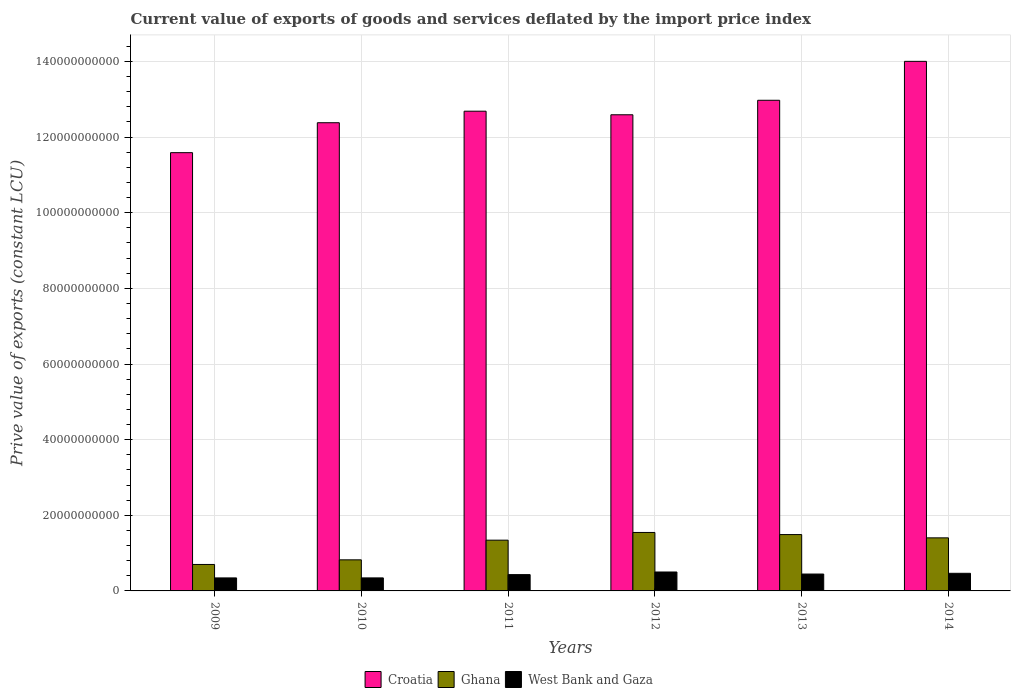How many different coloured bars are there?
Your response must be concise. 3. How many bars are there on the 6th tick from the right?
Your answer should be very brief. 3. What is the prive value of exports in Croatia in 2012?
Give a very brief answer. 1.26e+11. Across all years, what is the maximum prive value of exports in West Bank and Gaza?
Provide a short and direct response. 5.00e+09. Across all years, what is the minimum prive value of exports in Croatia?
Your response must be concise. 1.16e+11. In which year was the prive value of exports in Ghana minimum?
Provide a succinct answer. 2009. What is the total prive value of exports in Croatia in the graph?
Provide a succinct answer. 7.62e+11. What is the difference between the prive value of exports in Croatia in 2013 and that in 2014?
Provide a succinct answer. -1.03e+1. What is the difference between the prive value of exports in West Bank and Gaza in 2010 and the prive value of exports in Croatia in 2014?
Provide a succinct answer. -1.37e+11. What is the average prive value of exports in Ghana per year?
Your answer should be very brief. 1.22e+1. In the year 2012, what is the difference between the prive value of exports in West Bank and Gaza and prive value of exports in Ghana?
Provide a short and direct response. -1.05e+1. In how many years, is the prive value of exports in West Bank and Gaza greater than 108000000000 LCU?
Ensure brevity in your answer.  0. What is the ratio of the prive value of exports in Croatia in 2010 to that in 2011?
Your response must be concise. 0.98. What is the difference between the highest and the second highest prive value of exports in Croatia?
Ensure brevity in your answer.  1.03e+1. What is the difference between the highest and the lowest prive value of exports in Ghana?
Keep it short and to the point. 8.46e+09. In how many years, is the prive value of exports in West Bank and Gaza greater than the average prive value of exports in West Bank and Gaza taken over all years?
Give a very brief answer. 4. What does the 1st bar from the left in 2014 represents?
Offer a very short reply. Croatia. What does the 3rd bar from the right in 2012 represents?
Provide a succinct answer. Croatia. Is it the case that in every year, the sum of the prive value of exports in Croatia and prive value of exports in Ghana is greater than the prive value of exports in West Bank and Gaza?
Give a very brief answer. Yes. Does the graph contain any zero values?
Your answer should be compact. No. Does the graph contain grids?
Offer a terse response. Yes. How are the legend labels stacked?
Give a very brief answer. Horizontal. What is the title of the graph?
Provide a short and direct response. Current value of exports of goods and services deflated by the import price index. What is the label or title of the Y-axis?
Your response must be concise. Prive value of exports (constant LCU). What is the Prive value of exports (constant LCU) in Croatia in 2009?
Your response must be concise. 1.16e+11. What is the Prive value of exports (constant LCU) in Ghana in 2009?
Ensure brevity in your answer.  7.00e+09. What is the Prive value of exports (constant LCU) of West Bank and Gaza in 2009?
Provide a short and direct response. 3.44e+09. What is the Prive value of exports (constant LCU) of Croatia in 2010?
Provide a short and direct response. 1.24e+11. What is the Prive value of exports (constant LCU) in Ghana in 2010?
Your answer should be very brief. 8.22e+09. What is the Prive value of exports (constant LCU) of West Bank and Gaza in 2010?
Give a very brief answer. 3.44e+09. What is the Prive value of exports (constant LCU) in Croatia in 2011?
Make the answer very short. 1.27e+11. What is the Prive value of exports (constant LCU) of Ghana in 2011?
Offer a very short reply. 1.34e+1. What is the Prive value of exports (constant LCU) in West Bank and Gaza in 2011?
Make the answer very short. 4.31e+09. What is the Prive value of exports (constant LCU) of Croatia in 2012?
Make the answer very short. 1.26e+11. What is the Prive value of exports (constant LCU) of Ghana in 2012?
Offer a terse response. 1.55e+1. What is the Prive value of exports (constant LCU) of West Bank and Gaza in 2012?
Provide a succinct answer. 5.00e+09. What is the Prive value of exports (constant LCU) in Croatia in 2013?
Keep it short and to the point. 1.30e+11. What is the Prive value of exports (constant LCU) in Ghana in 2013?
Offer a terse response. 1.49e+1. What is the Prive value of exports (constant LCU) of West Bank and Gaza in 2013?
Keep it short and to the point. 4.46e+09. What is the Prive value of exports (constant LCU) of Croatia in 2014?
Offer a very short reply. 1.40e+11. What is the Prive value of exports (constant LCU) in Ghana in 2014?
Offer a very short reply. 1.40e+1. What is the Prive value of exports (constant LCU) in West Bank and Gaza in 2014?
Ensure brevity in your answer.  4.66e+09. Across all years, what is the maximum Prive value of exports (constant LCU) in Croatia?
Give a very brief answer. 1.40e+11. Across all years, what is the maximum Prive value of exports (constant LCU) of Ghana?
Your response must be concise. 1.55e+1. Across all years, what is the maximum Prive value of exports (constant LCU) in West Bank and Gaza?
Your answer should be compact. 5.00e+09. Across all years, what is the minimum Prive value of exports (constant LCU) of Croatia?
Give a very brief answer. 1.16e+11. Across all years, what is the minimum Prive value of exports (constant LCU) of Ghana?
Keep it short and to the point. 7.00e+09. Across all years, what is the minimum Prive value of exports (constant LCU) in West Bank and Gaza?
Provide a succinct answer. 3.44e+09. What is the total Prive value of exports (constant LCU) of Croatia in the graph?
Your answer should be very brief. 7.62e+11. What is the total Prive value of exports (constant LCU) of Ghana in the graph?
Offer a very short reply. 7.30e+1. What is the total Prive value of exports (constant LCU) of West Bank and Gaza in the graph?
Give a very brief answer. 2.53e+1. What is the difference between the Prive value of exports (constant LCU) of Croatia in 2009 and that in 2010?
Offer a terse response. -7.92e+09. What is the difference between the Prive value of exports (constant LCU) of Ghana in 2009 and that in 2010?
Make the answer very short. -1.22e+09. What is the difference between the Prive value of exports (constant LCU) in West Bank and Gaza in 2009 and that in 2010?
Make the answer very short. -4.18e+06. What is the difference between the Prive value of exports (constant LCU) of Croatia in 2009 and that in 2011?
Make the answer very short. -1.10e+1. What is the difference between the Prive value of exports (constant LCU) in Ghana in 2009 and that in 2011?
Your response must be concise. -6.42e+09. What is the difference between the Prive value of exports (constant LCU) in West Bank and Gaza in 2009 and that in 2011?
Keep it short and to the point. -8.70e+08. What is the difference between the Prive value of exports (constant LCU) in Croatia in 2009 and that in 2012?
Offer a terse response. -1.00e+1. What is the difference between the Prive value of exports (constant LCU) in Ghana in 2009 and that in 2012?
Offer a terse response. -8.46e+09. What is the difference between the Prive value of exports (constant LCU) in West Bank and Gaza in 2009 and that in 2012?
Provide a succinct answer. -1.56e+09. What is the difference between the Prive value of exports (constant LCU) of Croatia in 2009 and that in 2013?
Keep it short and to the point. -1.39e+1. What is the difference between the Prive value of exports (constant LCU) in Ghana in 2009 and that in 2013?
Provide a succinct answer. -7.90e+09. What is the difference between the Prive value of exports (constant LCU) in West Bank and Gaza in 2009 and that in 2013?
Your answer should be compact. -1.02e+09. What is the difference between the Prive value of exports (constant LCU) of Croatia in 2009 and that in 2014?
Ensure brevity in your answer.  -2.41e+1. What is the difference between the Prive value of exports (constant LCU) in Ghana in 2009 and that in 2014?
Provide a short and direct response. -7.03e+09. What is the difference between the Prive value of exports (constant LCU) of West Bank and Gaza in 2009 and that in 2014?
Offer a very short reply. -1.22e+09. What is the difference between the Prive value of exports (constant LCU) in Croatia in 2010 and that in 2011?
Provide a short and direct response. -3.05e+09. What is the difference between the Prive value of exports (constant LCU) in Ghana in 2010 and that in 2011?
Make the answer very short. -5.20e+09. What is the difference between the Prive value of exports (constant LCU) of West Bank and Gaza in 2010 and that in 2011?
Your response must be concise. -8.66e+08. What is the difference between the Prive value of exports (constant LCU) of Croatia in 2010 and that in 2012?
Provide a succinct answer. -2.11e+09. What is the difference between the Prive value of exports (constant LCU) in Ghana in 2010 and that in 2012?
Your answer should be compact. -7.24e+09. What is the difference between the Prive value of exports (constant LCU) of West Bank and Gaza in 2010 and that in 2012?
Your response must be concise. -1.56e+09. What is the difference between the Prive value of exports (constant LCU) in Croatia in 2010 and that in 2013?
Offer a terse response. -5.94e+09. What is the difference between the Prive value of exports (constant LCU) of Ghana in 2010 and that in 2013?
Offer a terse response. -6.68e+09. What is the difference between the Prive value of exports (constant LCU) of West Bank and Gaza in 2010 and that in 2013?
Provide a short and direct response. -1.02e+09. What is the difference between the Prive value of exports (constant LCU) in Croatia in 2010 and that in 2014?
Offer a terse response. -1.62e+1. What is the difference between the Prive value of exports (constant LCU) of Ghana in 2010 and that in 2014?
Provide a short and direct response. -5.81e+09. What is the difference between the Prive value of exports (constant LCU) of West Bank and Gaza in 2010 and that in 2014?
Make the answer very short. -1.21e+09. What is the difference between the Prive value of exports (constant LCU) of Croatia in 2011 and that in 2012?
Ensure brevity in your answer.  9.46e+08. What is the difference between the Prive value of exports (constant LCU) of Ghana in 2011 and that in 2012?
Offer a terse response. -2.04e+09. What is the difference between the Prive value of exports (constant LCU) of West Bank and Gaza in 2011 and that in 2012?
Provide a succinct answer. -6.93e+08. What is the difference between the Prive value of exports (constant LCU) of Croatia in 2011 and that in 2013?
Offer a terse response. -2.89e+09. What is the difference between the Prive value of exports (constant LCU) of Ghana in 2011 and that in 2013?
Keep it short and to the point. -1.48e+09. What is the difference between the Prive value of exports (constant LCU) of West Bank and Gaza in 2011 and that in 2013?
Offer a very short reply. -1.52e+08. What is the difference between the Prive value of exports (constant LCU) of Croatia in 2011 and that in 2014?
Make the answer very short. -1.32e+1. What is the difference between the Prive value of exports (constant LCU) of Ghana in 2011 and that in 2014?
Provide a short and direct response. -6.12e+08. What is the difference between the Prive value of exports (constant LCU) in West Bank and Gaza in 2011 and that in 2014?
Give a very brief answer. -3.47e+08. What is the difference between the Prive value of exports (constant LCU) of Croatia in 2012 and that in 2013?
Your answer should be very brief. -3.83e+09. What is the difference between the Prive value of exports (constant LCU) in Ghana in 2012 and that in 2013?
Ensure brevity in your answer.  5.57e+08. What is the difference between the Prive value of exports (constant LCU) in West Bank and Gaza in 2012 and that in 2013?
Ensure brevity in your answer.  5.41e+08. What is the difference between the Prive value of exports (constant LCU) of Croatia in 2012 and that in 2014?
Offer a terse response. -1.41e+1. What is the difference between the Prive value of exports (constant LCU) of Ghana in 2012 and that in 2014?
Your response must be concise. 1.43e+09. What is the difference between the Prive value of exports (constant LCU) of West Bank and Gaza in 2012 and that in 2014?
Provide a short and direct response. 3.47e+08. What is the difference between the Prive value of exports (constant LCU) of Croatia in 2013 and that in 2014?
Give a very brief answer. -1.03e+1. What is the difference between the Prive value of exports (constant LCU) of Ghana in 2013 and that in 2014?
Give a very brief answer. 8.69e+08. What is the difference between the Prive value of exports (constant LCU) of West Bank and Gaza in 2013 and that in 2014?
Ensure brevity in your answer.  -1.94e+08. What is the difference between the Prive value of exports (constant LCU) of Croatia in 2009 and the Prive value of exports (constant LCU) of Ghana in 2010?
Give a very brief answer. 1.08e+11. What is the difference between the Prive value of exports (constant LCU) in Croatia in 2009 and the Prive value of exports (constant LCU) in West Bank and Gaza in 2010?
Offer a very short reply. 1.12e+11. What is the difference between the Prive value of exports (constant LCU) in Ghana in 2009 and the Prive value of exports (constant LCU) in West Bank and Gaza in 2010?
Provide a short and direct response. 3.55e+09. What is the difference between the Prive value of exports (constant LCU) of Croatia in 2009 and the Prive value of exports (constant LCU) of Ghana in 2011?
Ensure brevity in your answer.  1.02e+11. What is the difference between the Prive value of exports (constant LCU) in Croatia in 2009 and the Prive value of exports (constant LCU) in West Bank and Gaza in 2011?
Offer a very short reply. 1.12e+11. What is the difference between the Prive value of exports (constant LCU) of Ghana in 2009 and the Prive value of exports (constant LCU) of West Bank and Gaza in 2011?
Make the answer very short. 2.69e+09. What is the difference between the Prive value of exports (constant LCU) of Croatia in 2009 and the Prive value of exports (constant LCU) of Ghana in 2012?
Give a very brief answer. 1.00e+11. What is the difference between the Prive value of exports (constant LCU) of Croatia in 2009 and the Prive value of exports (constant LCU) of West Bank and Gaza in 2012?
Give a very brief answer. 1.11e+11. What is the difference between the Prive value of exports (constant LCU) of Ghana in 2009 and the Prive value of exports (constant LCU) of West Bank and Gaza in 2012?
Provide a short and direct response. 1.99e+09. What is the difference between the Prive value of exports (constant LCU) of Croatia in 2009 and the Prive value of exports (constant LCU) of Ghana in 2013?
Make the answer very short. 1.01e+11. What is the difference between the Prive value of exports (constant LCU) in Croatia in 2009 and the Prive value of exports (constant LCU) in West Bank and Gaza in 2013?
Provide a short and direct response. 1.11e+11. What is the difference between the Prive value of exports (constant LCU) in Ghana in 2009 and the Prive value of exports (constant LCU) in West Bank and Gaza in 2013?
Make the answer very short. 2.53e+09. What is the difference between the Prive value of exports (constant LCU) in Croatia in 2009 and the Prive value of exports (constant LCU) in Ghana in 2014?
Give a very brief answer. 1.02e+11. What is the difference between the Prive value of exports (constant LCU) of Croatia in 2009 and the Prive value of exports (constant LCU) of West Bank and Gaza in 2014?
Ensure brevity in your answer.  1.11e+11. What is the difference between the Prive value of exports (constant LCU) of Ghana in 2009 and the Prive value of exports (constant LCU) of West Bank and Gaza in 2014?
Your answer should be very brief. 2.34e+09. What is the difference between the Prive value of exports (constant LCU) of Croatia in 2010 and the Prive value of exports (constant LCU) of Ghana in 2011?
Offer a terse response. 1.10e+11. What is the difference between the Prive value of exports (constant LCU) in Croatia in 2010 and the Prive value of exports (constant LCU) in West Bank and Gaza in 2011?
Your answer should be very brief. 1.19e+11. What is the difference between the Prive value of exports (constant LCU) in Ghana in 2010 and the Prive value of exports (constant LCU) in West Bank and Gaza in 2011?
Ensure brevity in your answer.  3.91e+09. What is the difference between the Prive value of exports (constant LCU) of Croatia in 2010 and the Prive value of exports (constant LCU) of Ghana in 2012?
Your response must be concise. 1.08e+11. What is the difference between the Prive value of exports (constant LCU) in Croatia in 2010 and the Prive value of exports (constant LCU) in West Bank and Gaza in 2012?
Offer a very short reply. 1.19e+11. What is the difference between the Prive value of exports (constant LCU) in Ghana in 2010 and the Prive value of exports (constant LCU) in West Bank and Gaza in 2012?
Offer a very short reply. 3.22e+09. What is the difference between the Prive value of exports (constant LCU) of Croatia in 2010 and the Prive value of exports (constant LCU) of Ghana in 2013?
Offer a very short reply. 1.09e+11. What is the difference between the Prive value of exports (constant LCU) in Croatia in 2010 and the Prive value of exports (constant LCU) in West Bank and Gaza in 2013?
Offer a very short reply. 1.19e+11. What is the difference between the Prive value of exports (constant LCU) in Ghana in 2010 and the Prive value of exports (constant LCU) in West Bank and Gaza in 2013?
Your answer should be compact. 3.76e+09. What is the difference between the Prive value of exports (constant LCU) of Croatia in 2010 and the Prive value of exports (constant LCU) of Ghana in 2014?
Make the answer very short. 1.10e+11. What is the difference between the Prive value of exports (constant LCU) in Croatia in 2010 and the Prive value of exports (constant LCU) in West Bank and Gaza in 2014?
Offer a terse response. 1.19e+11. What is the difference between the Prive value of exports (constant LCU) of Ghana in 2010 and the Prive value of exports (constant LCU) of West Bank and Gaza in 2014?
Provide a succinct answer. 3.56e+09. What is the difference between the Prive value of exports (constant LCU) in Croatia in 2011 and the Prive value of exports (constant LCU) in Ghana in 2012?
Your answer should be compact. 1.11e+11. What is the difference between the Prive value of exports (constant LCU) in Croatia in 2011 and the Prive value of exports (constant LCU) in West Bank and Gaza in 2012?
Your answer should be compact. 1.22e+11. What is the difference between the Prive value of exports (constant LCU) in Ghana in 2011 and the Prive value of exports (constant LCU) in West Bank and Gaza in 2012?
Provide a short and direct response. 8.42e+09. What is the difference between the Prive value of exports (constant LCU) of Croatia in 2011 and the Prive value of exports (constant LCU) of Ghana in 2013?
Provide a succinct answer. 1.12e+11. What is the difference between the Prive value of exports (constant LCU) of Croatia in 2011 and the Prive value of exports (constant LCU) of West Bank and Gaza in 2013?
Provide a succinct answer. 1.22e+11. What is the difference between the Prive value of exports (constant LCU) of Ghana in 2011 and the Prive value of exports (constant LCU) of West Bank and Gaza in 2013?
Offer a very short reply. 8.96e+09. What is the difference between the Prive value of exports (constant LCU) in Croatia in 2011 and the Prive value of exports (constant LCU) in Ghana in 2014?
Offer a very short reply. 1.13e+11. What is the difference between the Prive value of exports (constant LCU) of Croatia in 2011 and the Prive value of exports (constant LCU) of West Bank and Gaza in 2014?
Provide a short and direct response. 1.22e+11. What is the difference between the Prive value of exports (constant LCU) in Ghana in 2011 and the Prive value of exports (constant LCU) in West Bank and Gaza in 2014?
Keep it short and to the point. 8.76e+09. What is the difference between the Prive value of exports (constant LCU) in Croatia in 2012 and the Prive value of exports (constant LCU) in Ghana in 2013?
Offer a very short reply. 1.11e+11. What is the difference between the Prive value of exports (constant LCU) of Croatia in 2012 and the Prive value of exports (constant LCU) of West Bank and Gaza in 2013?
Your response must be concise. 1.21e+11. What is the difference between the Prive value of exports (constant LCU) in Ghana in 2012 and the Prive value of exports (constant LCU) in West Bank and Gaza in 2013?
Your response must be concise. 1.10e+1. What is the difference between the Prive value of exports (constant LCU) of Croatia in 2012 and the Prive value of exports (constant LCU) of Ghana in 2014?
Provide a short and direct response. 1.12e+11. What is the difference between the Prive value of exports (constant LCU) of Croatia in 2012 and the Prive value of exports (constant LCU) of West Bank and Gaza in 2014?
Make the answer very short. 1.21e+11. What is the difference between the Prive value of exports (constant LCU) of Ghana in 2012 and the Prive value of exports (constant LCU) of West Bank and Gaza in 2014?
Keep it short and to the point. 1.08e+1. What is the difference between the Prive value of exports (constant LCU) in Croatia in 2013 and the Prive value of exports (constant LCU) in Ghana in 2014?
Offer a terse response. 1.16e+11. What is the difference between the Prive value of exports (constant LCU) in Croatia in 2013 and the Prive value of exports (constant LCU) in West Bank and Gaza in 2014?
Give a very brief answer. 1.25e+11. What is the difference between the Prive value of exports (constant LCU) in Ghana in 2013 and the Prive value of exports (constant LCU) in West Bank and Gaza in 2014?
Make the answer very short. 1.02e+1. What is the average Prive value of exports (constant LCU) of Croatia per year?
Your response must be concise. 1.27e+11. What is the average Prive value of exports (constant LCU) of Ghana per year?
Provide a short and direct response. 1.22e+1. What is the average Prive value of exports (constant LCU) of West Bank and Gaza per year?
Offer a terse response. 4.22e+09. In the year 2009, what is the difference between the Prive value of exports (constant LCU) in Croatia and Prive value of exports (constant LCU) in Ghana?
Your answer should be very brief. 1.09e+11. In the year 2009, what is the difference between the Prive value of exports (constant LCU) in Croatia and Prive value of exports (constant LCU) in West Bank and Gaza?
Make the answer very short. 1.12e+11. In the year 2009, what is the difference between the Prive value of exports (constant LCU) in Ghana and Prive value of exports (constant LCU) in West Bank and Gaza?
Provide a short and direct response. 3.56e+09. In the year 2010, what is the difference between the Prive value of exports (constant LCU) of Croatia and Prive value of exports (constant LCU) of Ghana?
Make the answer very short. 1.16e+11. In the year 2010, what is the difference between the Prive value of exports (constant LCU) in Croatia and Prive value of exports (constant LCU) in West Bank and Gaza?
Give a very brief answer. 1.20e+11. In the year 2010, what is the difference between the Prive value of exports (constant LCU) in Ghana and Prive value of exports (constant LCU) in West Bank and Gaza?
Offer a very short reply. 4.78e+09. In the year 2011, what is the difference between the Prive value of exports (constant LCU) in Croatia and Prive value of exports (constant LCU) in Ghana?
Your answer should be compact. 1.13e+11. In the year 2011, what is the difference between the Prive value of exports (constant LCU) in Croatia and Prive value of exports (constant LCU) in West Bank and Gaza?
Keep it short and to the point. 1.23e+11. In the year 2011, what is the difference between the Prive value of exports (constant LCU) in Ghana and Prive value of exports (constant LCU) in West Bank and Gaza?
Your answer should be compact. 9.11e+09. In the year 2012, what is the difference between the Prive value of exports (constant LCU) of Croatia and Prive value of exports (constant LCU) of Ghana?
Provide a succinct answer. 1.10e+11. In the year 2012, what is the difference between the Prive value of exports (constant LCU) in Croatia and Prive value of exports (constant LCU) in West Bank and Gaza?
Your answer should be very brief. 1.21e+11. In the year 2012, what is the difference between the Prive value of exports (constant LCU) in Ghana and Prive value of exports (constant LCU) in West Bank and Gaza?
Offer a terse response. 1.05e+1. In the year 2013, what is the difference between the Prive value of exports (constant LCU) in Croatia and Prive value of exports (constant LCU) in Ghana?
Your response must be concise. 1.15e+11. In the year 2013, what is the difference between the Prive value of exports (constant LCU) in Croatia and Prive value of exports (constant LCU) in West Bank and Gaza?
Offer a terse response. 1.25e+11. In the year 2013, what is the difference between the Prive value of exports (constant LCU) of Ghana and Prive value of exports (constant LCU) of West Bank and Gaza?
Give a very brief answer. 1.04e+1. In the year 2014, what is the difference between the Prive value of exports (constant LCU) in Croatia and Prive value of exports (constant LCU) in Ghana?
Your response must be concise. 1.26e+11. In the year 2014, what is the difference between the Prive value of exports (constant LCU) in Croatia and Prive value of exports (constant LCU) in West Bank and Gaza?
Provide a succinct answer. 1.35e+11. In the year 2014, what is the difference between the Prive value of exports (constant LCU) in Ghana and Prive value of exports (constant LCU) in West Bank and Gaza?
Provide a short and direct response. 9.37e+09. What is the ratio of the Prive value of exports (constant LCU) in Croatia in 2009 to that in 2010?
Your answer should be very brief. 0.94. What is the ratio of the Prive value of exports (constant LCU) in Ghana in 2009 to that in 2010?
Make the answer very short. 0.85. What is the ratio of the Prive value of exports (constant LCU) of Croatia in 2009 to that in 2011?
Give a very brief answer. 0.91. What is the ratio of the Prive value of exports (constant LCU) of Ghana in 2009 to that in 2011?
Give a very brief answer. 0.52. What is the ratio of the Prive value of exports (constant LCU) in West Bank and Gaza in 2009 to that in 2011?
Offer a terse response. 0.8. What is the ratio of the Prive value of exports (constant LCU) of Croatia in 2009 to that in 2012?
Give a very brief answer. 0.92. What is the ratio of the Prive value of exports (constant LCU) of Ghana in 2009 to that in 2012?
Provide a short and direct response. 0.45. What is the ratio of the Prive value of exports (constant LCU) in West Bank and Gaza in 2009 to that in 2012?
Offer a very short reply. 0.69. What is the ratio of the Prive value of exports (constant LCU) in Croatia in 2009 to that in 2013?
Offer a very short reply. 0.89. What is the ratio of the Prive value of exports (constant LCU) of Ghana in 2009 to that in 2013?
Your response must be concise. 0.47. What is the ratio of the Prive value of exports (constant LCU) in West Bank and Gaza in 2009 to that in 2013?
Ensure brevity in your answer.  0.77. What is the ratio of the Prive value of exports (constant LCU) of Croatia in 2009 to that in 2014?
Your answer should be very brief. 0.83. What is the ratio of the Prive value of exports (constant LCU) of Ghana in 2009 to that in 2014?
Your response must be concise. 0.5. What is the ratio of the Prive value of exports (constant LCU) in West Bank and Gaza in 2009 to that in 2014?
Your response must be concise. 0.74. What is the ratio of the Prive value of exports (constant LCU) of Croatia in 2010 to that in 2011?
Your response must be concise. 0.98. What is the ratio of the Prive value of exports (constant LCU) in Ghana in 2010 to that in 2011?
Ensure brevity in your answer.  0.61. What is the ratio of the Prive value of exports (constant LCU) of West Bank and Gaza in 2010 to that in 2011?
Your answer should be very brief. 0.8. What is the ratio of the Prive value of exports (constant LCU) of Croatia in 2010 to that in 2012?
Keep it short and to the point. 0.98. What is the ratio of the Prive value of exports (constant LCU) in Ghana in 2010 to that in 2012?
Keep it short and to the point. 0.53. What is the ratio of the Prive value of exports (constant LCU) in West Bank and Gaza in 2010 to that in 2012?
Offer a terse response. 0.69. What is the ratio of the Prive value of exports (constant LCU) of Croatia in 2010 to that in 2013?
Provide a short and direct response. 0.95. What is the ratio of the Prive value of exports (constant LCU) in Ghana in 2010 to that in 2013?
Your answer should be very brief. 0.55. What is the ratio of the Prive value of exports (constant LCU) of West Bank and Gaza in 2010 to that in 2013?
Offer a very short reply. 0.77. What is the ratio of the Prive value of exports (constant LCU) in Croatia in 2010 to that in 2014?
Provide a short and direct response. 0.88. What is the ratio of the Prive value of exports (constant LCU) in Ghana in 2010 to that in 2014?
Provide a short and direct response. 0.59. What is the ratio of the Prive value of exports (constant LCU) of West Bank and Gaza in 2010 to that in 2014?
Provide a succinct answer. 0.74. What is the ratio of the Prive value of exports (constant LCU) of Croatia in 2011 to that in 2012?
Keep it short and to the point. 1.01. What is the ratio of the Prive value of exports (constant LCU) of Ghana in 2011 to that in 2012?
Your response must be concise. 0.87. What is the ratio of the Prive value of exports (constant LCU) of West Bank and Gaza in 2011 to that in 2012?
Provide a succinct answer. 0.86. What is the ratio of the Prive value of exports (constant LCU) of Croatia in 2011 to that in 2013?
Provide a short and direct response. 0.98. What is the ratio of the Prive value of exports (constant LCU) of Ghana in 2011 to that in 2013?
Offer a terse response. 0.9. What is the ratio of the Prive value of exports (constant LCU) in West Bank and Gaza in 2011 to that in 2013?
Give a very brief answer. 0.97. What is the ratio of the Prive value of exports (constant LCU) in Croatia in 2011 to that in 2014?
Your response must be concise. 0.91. What is the ratio of the Prive value of exports (constant LCU) in Ghana in 2011 to that in 2014?
Make the answer very short. 0.96. What is the ratio of the Prive value of exports (constant LCU) in West Bank and Gaza in 2011 to that in 2014?
Offer a very short reply. 0.93. What is the ratio of the Prive value of exports (constant LCU) of Croatia in 2012 to that in 2013?
Your answer should be very brief. 0.97. What is the ratio of the Prive value of exports (constant LCU) in Ghana in 2012 to that in 2013?
Your answer should be very brief. 1.04. What is the ratio of the Prive value of exports (constant LCU) in West Bank and Gaza in 2012 to that in 2013?
Offer a terse response. 1.12. What is the ratio of the Prive value of exports (constant LCU) of Croatia in 2012 to that in 2014?
Offer a terse response. 0.9. What is the ratio of the Prive value of exports (constant LCU) in Ghana in 2012 to that in 2014?
Offer a terse response. 1.1. What is the ratio of the Prive value of exports (constant LCU) in West Bank and Gaza in 2012 to that in 2014?
Your answer should be very brief. 1.07. What is the ratio of the Prive value of exports (constant LCU) in Croatia in 2013 to that in 2014?
Your response must be concise. 0.93. What is the ratio of the Prive value of exports (constant LCU) of Ghana in 2013 to that in 2014?
Your answer should be very brief. 1.06. What is the ratio of the Prive value of exports (constant LCU) of West Bank and Gaza in 2013 to that in 2014?
Offer a terse response. 0.96. What is the difference between the highest and the second highest Prive value of exports (constant LCU) in Croatia?
Your answer should be compact. 1.03e+1. What is the difference between the highest and the second highest Prive value of exports (constant LCU) of Ghana?
Ensure brevity in your answer.  5.57e+08. What is the difference between the highest and the second highest Prive value of exports (constant LCU) in West Bank and Gaza?
Offer a very short reply. 3.47e+08. What is the difference between the highest and the lowest Prive value of exports (constant LCU) of Croatia?
Give a very brief answer. 2.41e+1. What is the difference between the highest and the lowest Prive value of exports (constant LCU) in Ghana?
Provide a short and direct response. 8.46e+09. What is the difference between the highest and the lowest Prive value of exports (constant LCU) of West Bank and Gaza?
Offer a very short reply. 1.56e+09. 